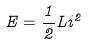Convert formula to latex. <formula><loc_0><loc_0><loc_500><loc_500>E = \frac { 1 } { 2 } L i ^ { 2 }</formula> 